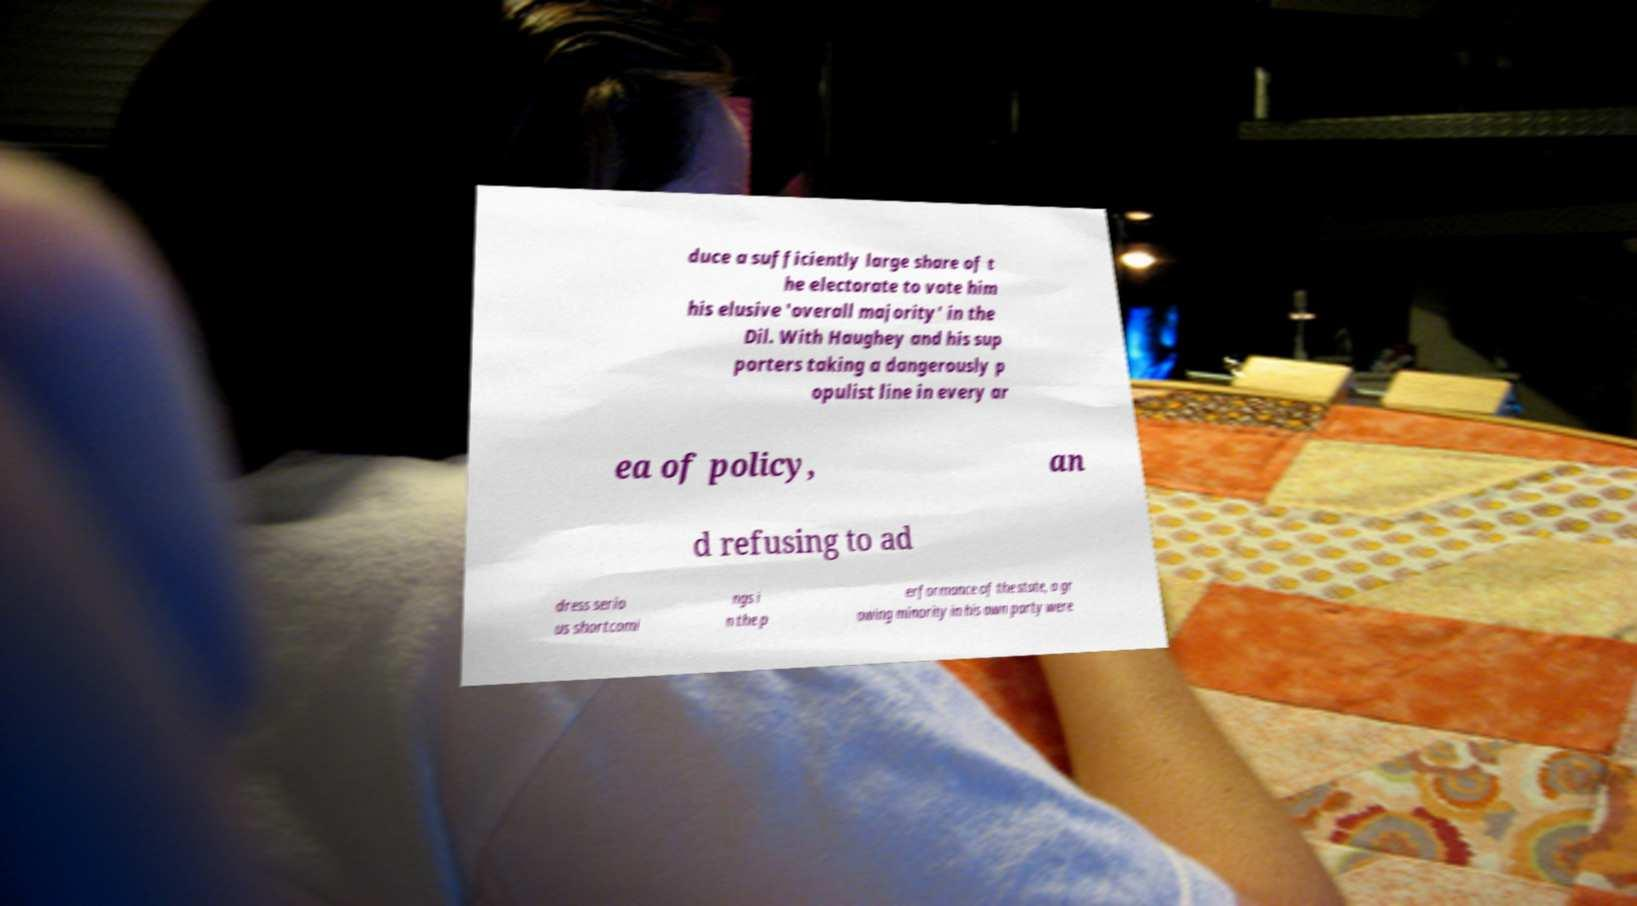What messages or text are displayed in this image? I need them in a readable, typed format. duce a sufficiently large share of t he electorate to vote him his elusive 'overall majority' in the Dil. With Haughey and his sup porters taking a dangerously p opulist line in every ar ea of policy, an d refusing to ad dress serio us shortcomi ngs i n the p erformance of the state, a gr owing minority in his own party were 